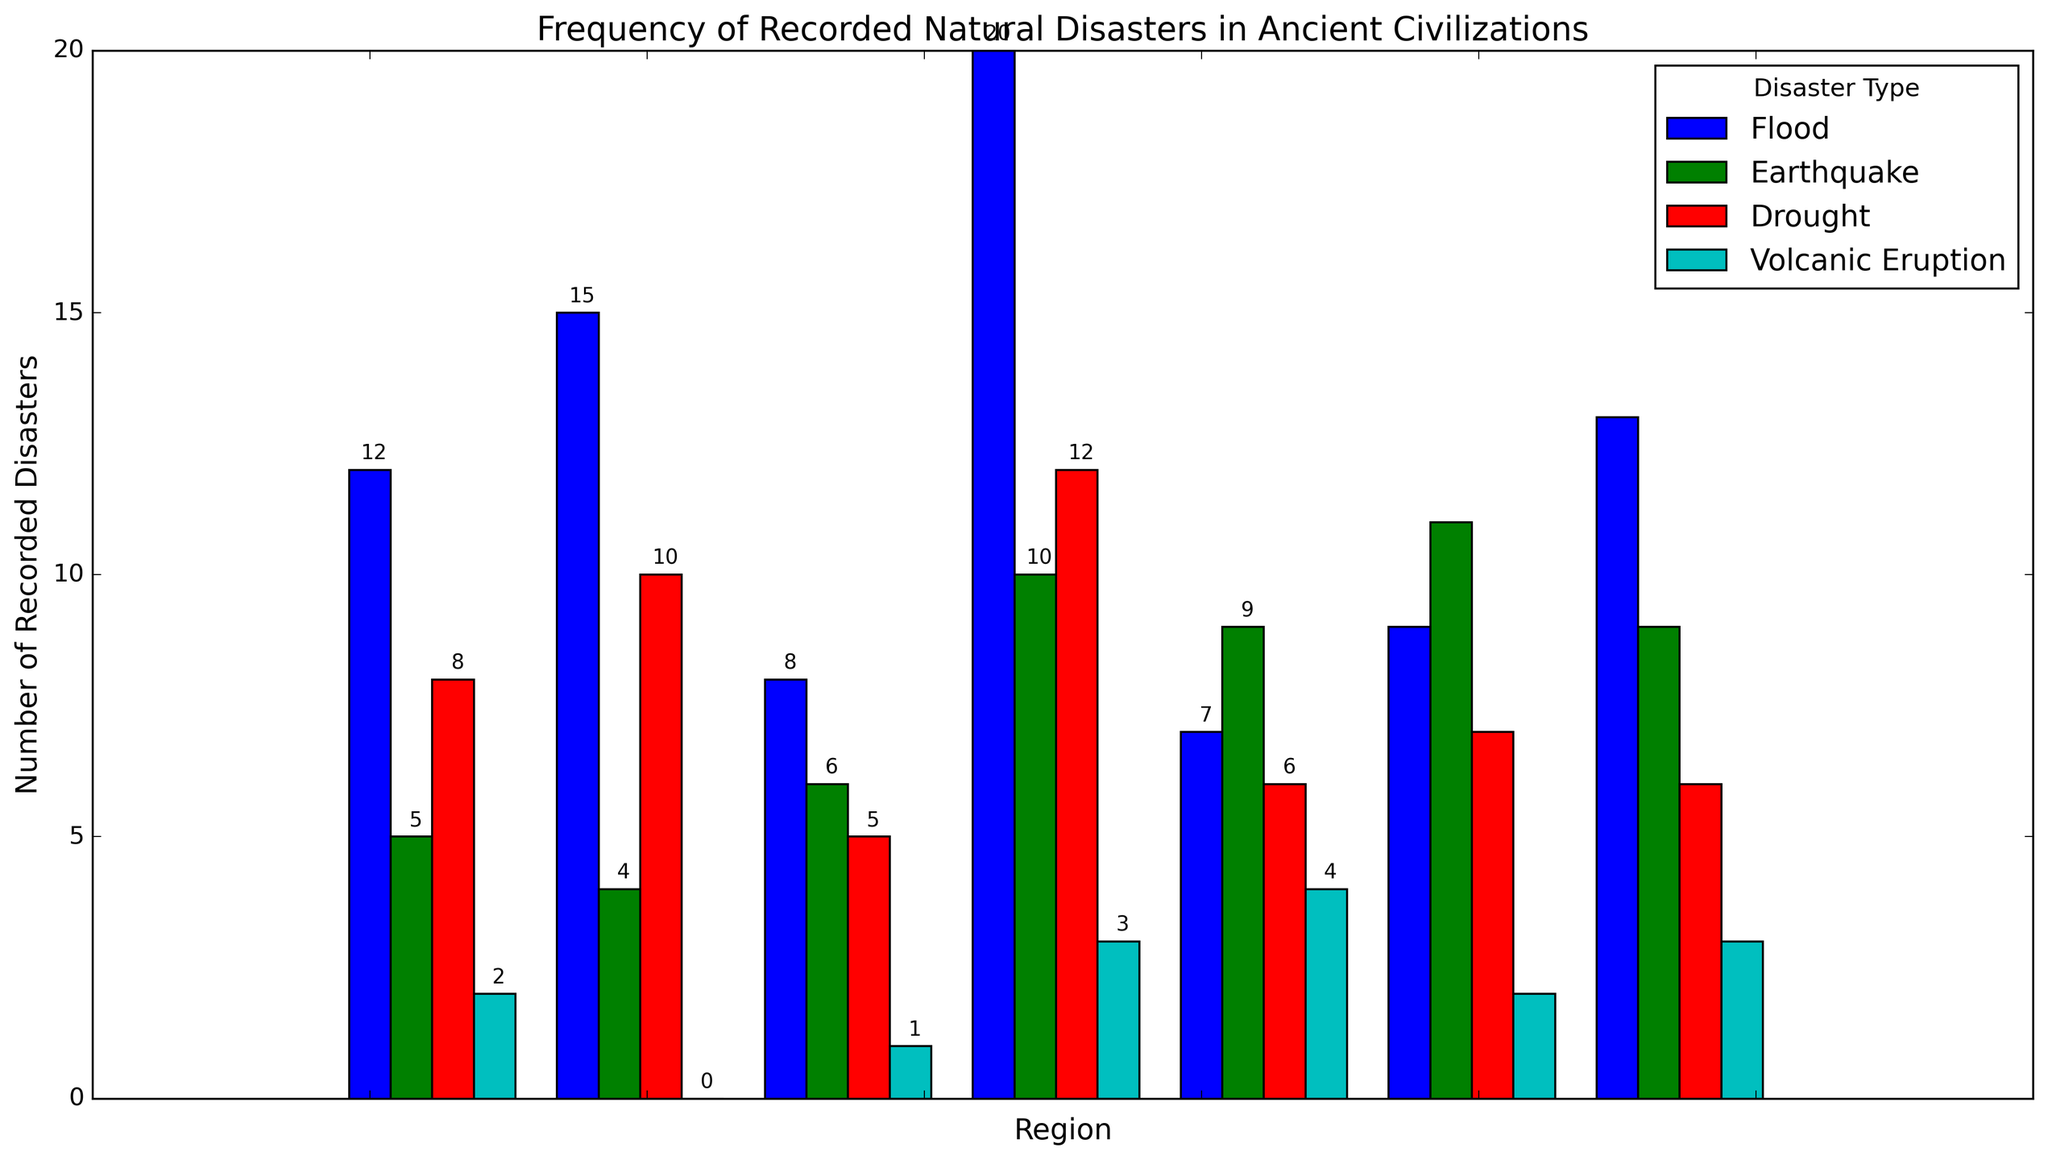Which region recorded the highest number of floods? By observing the bar heights, the highest bar representing floods is in Ancient China.
Answer: Ancient China Which disaster type was recorded the least in Mesopotamia? Check the shortest bar in the Mesopotamia group, which represents Volcanic Eruption with a height of 2.
Answer: Volcanic Eruption How many more floods were recorded in Egypt compared to the Indus Valley? Egypt recorded 15 floods, while the Indus Valley recorded 8. The difference is 15 - 8.
Answer: 7 Which two regions have the same number of recorded volcanic eruptions? The height of the bars for volcanic eruptions in Mesopotamia and Ancient Greece both show a value of 2 each.
Answer: Mesopotamia, Ancient Greece What is the total number of recorded earthquakes in Mesoamerica and Ancient Rome combined? Mesoamerica has 9 recorded earthquakes, and Ancient Rome has 9 as well. The total is 9 + 9.
Answer: 18 Which disaster type recorded the highest frequency across all regions? The tallest bar across all regions belongs to floods in Ancient China, indicating the highest overall frequency for floods.
Answer: Flood What is the difference in the number of recorded droughts between Egypt and Ancient Greece? Egypt recorded 10 droughts, while Ancient Greece recorded 7. The difference is 10 - 7.
Answer: 3 Compare the number of recorded floods between Mesopotamia and Mesoamerica. Which region had more? Mesopotamia recorded 12 floods, and Mesoamerica recorded 7 floods. Mesopotamia recorded more.
Answer: Mesopotamia Which region has the highest number of recorded earthquakes? The tallest bar representing earthquakes is in Ancient Greece with a height of 11.
Answer: Ancient Greece Sum all the recorded natural disasters in Ancient China. Adding up all the types in Ancient China: 20 (Flood) + 10 (Earthquake) + 12 (Drought) + 3 (Volcanic Eruption) = 45.
Answer: 45 